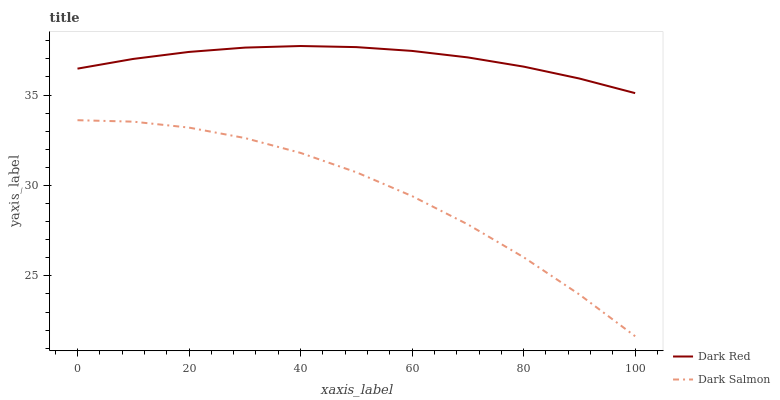Does Dark Salmon have the minimum area under the curve?
Answer yes or no. Yes. Does Dark Red have the maximum area under the curve?
Answer yes or no. Yes. Does Dark Salmon have the maximum area under the curve?
Answer yes or no. No. Is Dark Red the smoothest?
Answer yes or no. Yes. Is Dark Salmon the roughest?
Answer yes or no. Yes. Is Dark Salmon the smoothest?
Answer yes or no. No. Does Dark Salmon have the lowest value?
Answer yes or no. Yes. Does Dark Red have the highest value?
Answer yes or no. Yes. Does Dark Salmon have the highest value?
Answer yes or no. No. Is Dark Salmon less than Dark Red?
Answer yes or no. Yes. Is Dark Red greater than Dark Salmon?
Answer yes or no. Yes. Does Dark Salmon intersect Dark Red?
Answer yes or no. No. 